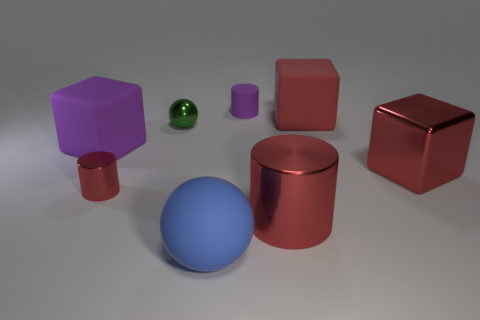Can you compare the sizes of the objects? Sure, comparing the sizes, the blue sphere and the red cylinder seem to be the largest objects in the scene. The red cube on the right and the purple cube seem to be of a similar size, while the small green sphere is the smallest object. The purple cylinder and the small red cube to its left are mid-sized when compared to the rest. 